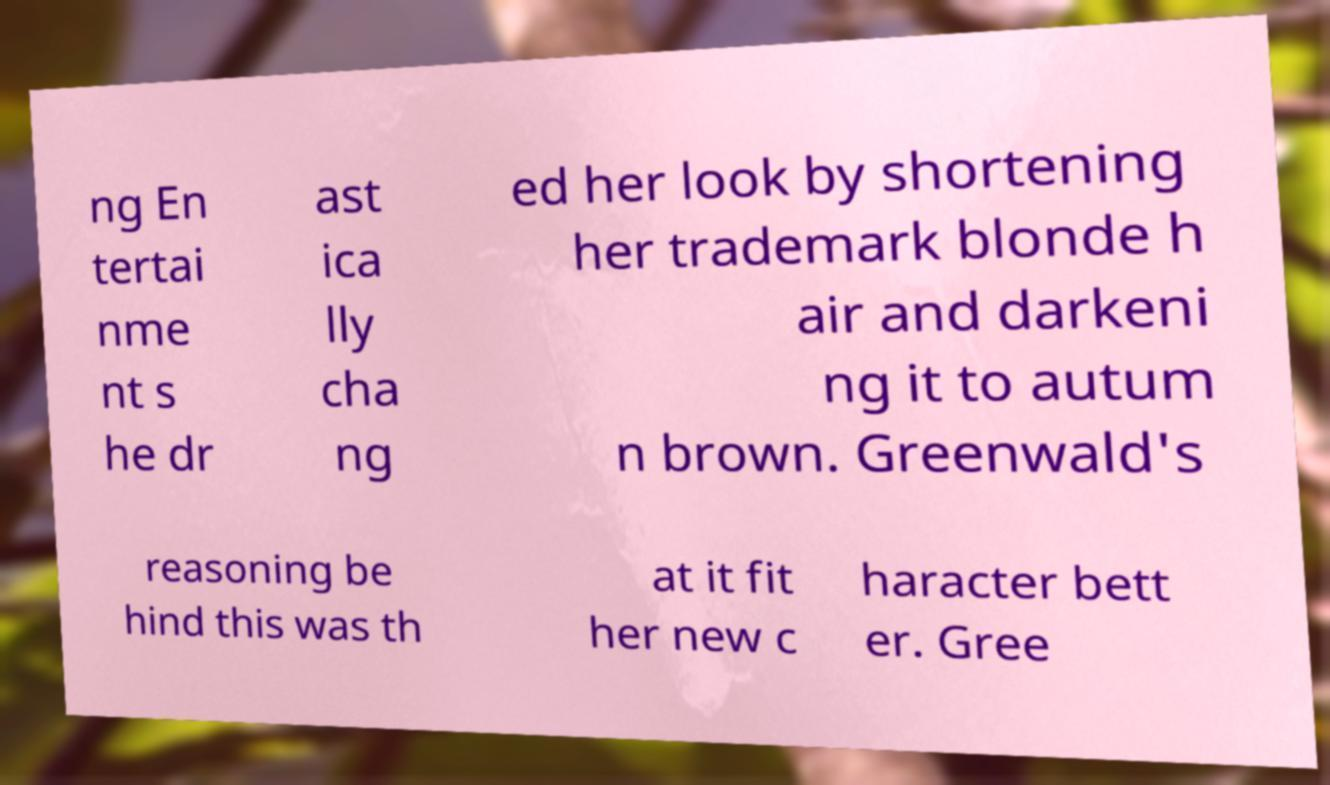Could you extract and type out the text from this image? ng En tertai nme nt s he dr ast ica lly cha ng ed her look by shortening her trademark blonde h air and darkeni ng it to autum n brown. Greenwald's reasoning be hind this was th at it fit her new c haracter bett er. Gree 